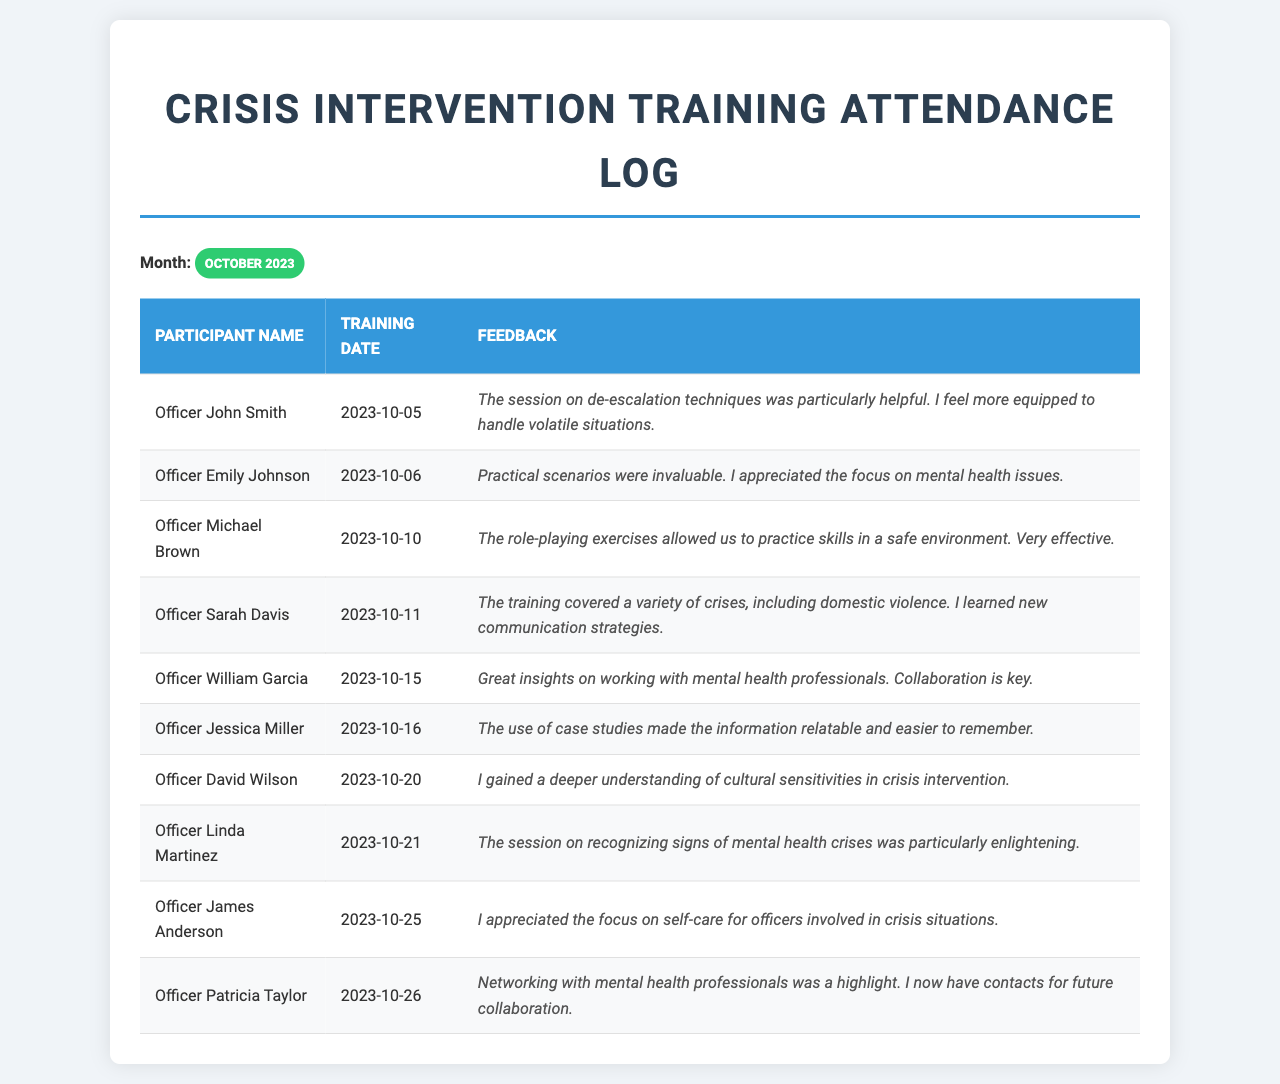What is the date of Officer John Smith's training? The document lists Officer John Smith's training date as October 5, 2023.
Answer: October 5, 2023 What feedback did Officer Emily Johnson provide? Officer Emily Johnson noted that practical scenarios were invaluable and appreciated the focus on mental health issues.
Answer: Practical scenarios were invaluable How many officers attended training on October 21? The document indicates that Officer Linda Martinez attended training on October 21, 2023, making the total count one.
Answer: 1 What is a key topic covered in Officer Sarah Davis's feedback? Officer Sarah Davis mentioned learning new communication strategies related to crises, including domestic violence.
Answer: New communication strategies Which officer gained insights on collaborating with mental health professionals? Officer William Garcia provided feedback on the importance of collaboration with mental health professionals.
Answer: Officer William Garcia What was the primary focus of the training on October 26 according to Officer Patricia Taylor? Officer Patricia Taylor highlighted networking with mental health professionals as a significant aspect of the training.
Answer: Networking with mental health professionals How many training sessions were held in total based on the document? The document lists 10 unique training sessions for different officers throughout October 2023.
Answer: 10 What feedback item was described as particularly enlightening by Officer Linda Martinez? Officer Linda Martinez found the session on recognizing signs of mental health crises especially enlightening.
Answer: Recognizing signs of mental health crises What was a common theme noted in the feedback from officers? A common theme in the feedback was the emphasis on mental health issues and crisis intervention strategies.
Answer: Emphasis on mental health issues 